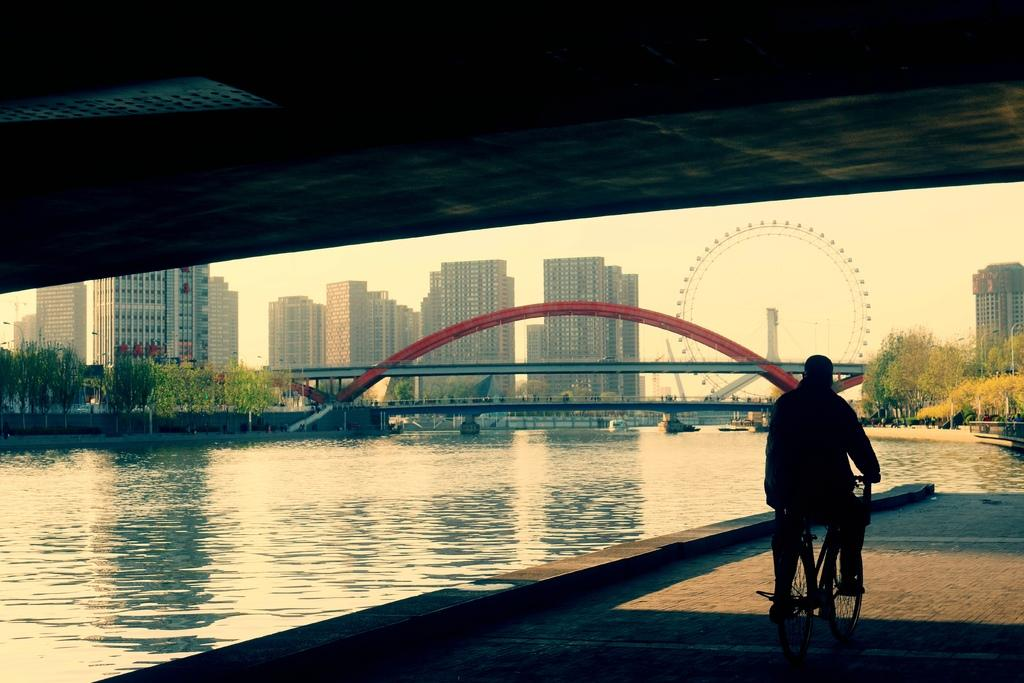What is the man in the image doing? A man is riding a bicycle in the image. What is the man passing under in the image? The man is passing under a bridge in the image. Where is the bridge located? The bridge is located by the side of a river in the image. What else can be seen in the background of the image? There is another bridge at a distance and a giant wheel in the background. What type of structures are visible in the background? There are buildings in the background of the image. What type of flower is the man holding while riding the bicycle? There is no flower present in the image; the man is riding a bicycle and passing under a bridge. 